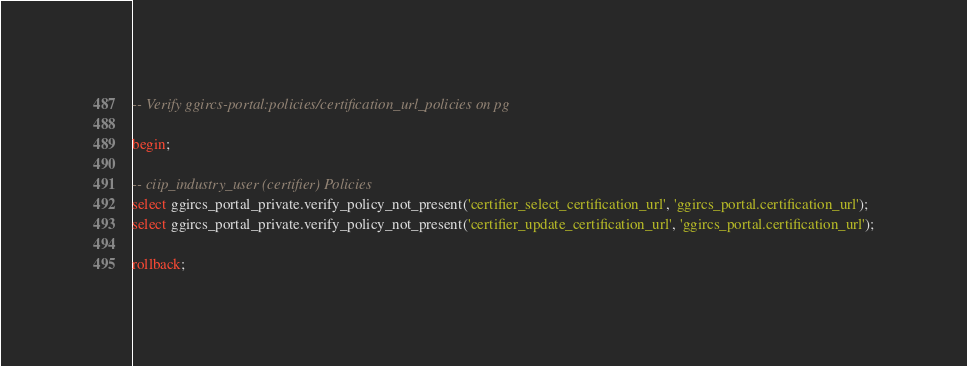<code> <loc_0><loc_0><loc_500><loc_500><_SQL_>-- Verify ggircs-portal:policies/certification_url_policies on pg

begin;

-- ciip_industry_user (certifier) Policies
select ggircs_portal_private.verify_policy_not_present('certifier_select_certification_url', 'ggircs_portal.certification_url');
select ggircs_portal_private.verify_policy_not_present('certifier_update_certification_url', 'ggircs_portal.certification_url');

rollback;
</code> 